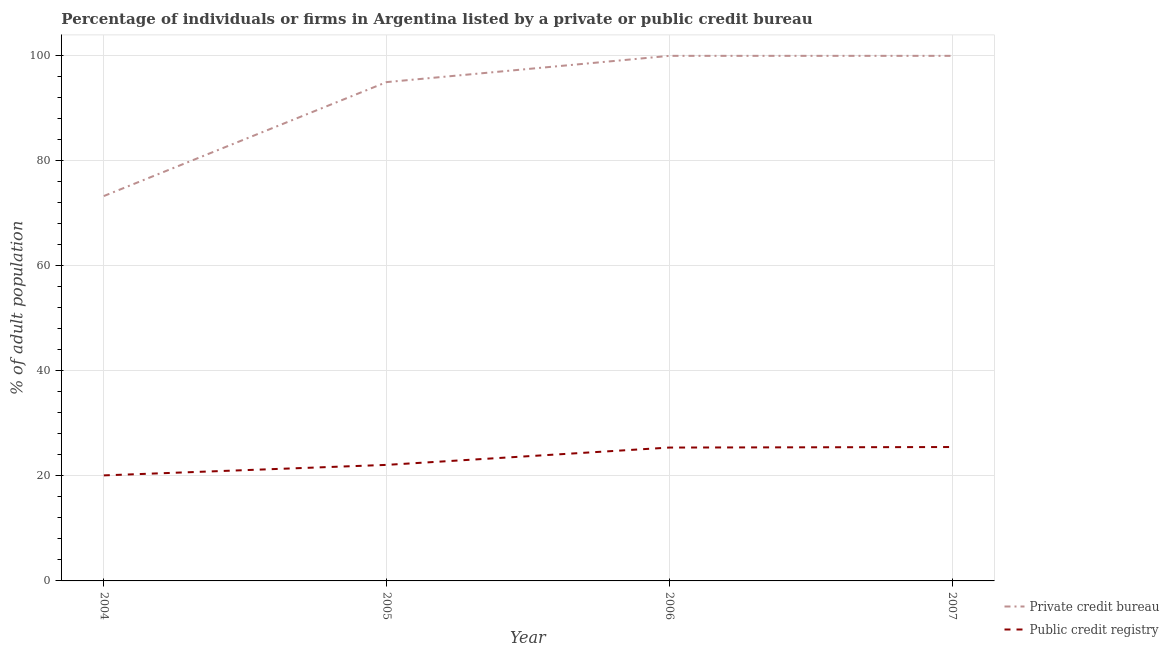How many different coloured lines are there?
Keep it short and to the point. 2. Does the line corresponding to percentage of firms listed by private credit bureau intersect with the line corresponding to percentage of firms listed by public credit bureau?
Your answer should be very brief. No. What is the percentage of firms listed by public credit bureau in 2004?
Give a very brief answer. 20.1. Across all years, what is the maximum percentage of firms listed by public credit bureau?
Give a very brief answer. 25.5. Across all years, what is the minimum percentage of firms listed by private credit bureau?
Provide a short and direct response. 73.3. In which year was the percentage of firms listed by public credit bureau maximum?
Give a very brief answer. 2007. In which year was the percentage of firms listed by private credit bureau minimum?
Give a very brief answer. 2004. What is the total percentage of firms listed by public credit bureau in the graph?
Keep it short and to the point. 93.1. What is the difference between the percentage of firms listed by public credit bureau in 2004 and that in 2007?
Give a very brief answer. -5.4. What is the difference between the percentage of firms listed by private credit bureau in 2004 and the percentage of firms listed by public credit bureau in 2007?
Offer a very short reply. 47.8. What is the average percentage of firms listed by public credit bureau per year?
Offer a terse response. 23.27. In the year 2005, what is the difference between the percentage of firms listed by private credit bureau and percentage of firms listed by public credit bureau?
Your answer should be very brief. 72.9. What is the ratio of the percentage of firms listed by public credit bureau in 2004 to that in 2007?
Give a very brief answer. 0.79. Is the percentage of firms listed by private credit bureau in 2004 less than that in 2007?
Provide a short and direct response. Yes. Is the difference between the percentage of firms listed by public credit bureau in 2005 and 2006 greater than the difference between the percentage of firms listed by private credit bureau in 2005 and 2006?
Ensure brevity in your answer.  Yes. What is the difference between the highest and the lowest percentage of firms listed by private credit bureau?
Provide a short and direct response. 26.7. In how many years, is the percentage of firms listed by public credit bureau greater than the average percentage of firms listed by public credit bureau taken over all years?
Provide a short and direct response. 2. Is the sum of the percentage of firms listed by public credit bureau in 2004 and 2007 greater than the maximum percentage of firms listed by private credit bureau across all years?
Offer a terse response. No. Is the percentage of firms listed by public credit bureau strictly greater than the percentage of firms listed by private credit bureau over the years?
Offer a terse response. No. How many lines are there?
Your response must be concise. 2. What is the difference between two consecutive major ticks on the Y-axis?
Keep it short and to the point. 20. Does the graph contain grids?
Your answer should be very brief. Yes. How many legend labels are there?
Ensure brevity in your answer.  2. What is the title of the graph?
Provide a succinct answer. Percentage of individuals or firms in Argentina listed by a private or public credit bureau. Does "Diarrhea" appear as one of the legend labels in the graph?
Make the answer very short. No. What is the label or title of the X-axis?
Your response must be concise. Year. What is the label or title of the Y-axis?
Ensure brevity in your answer.  % of adult population. What is the % of adult population in Private credit bureau in 2004?
Make the answer very short. 73.3. What is the % of adult population in Public credit registry in 2004?
Provide a short and direct response. 20.1. What is the % of adult population in Public credit registry in 2005?
Provide a short and direct response. 22.1. What is the % of adult population in Public credit registry in 2006?
Your response must be concise. 25.4. What is the % of adult population of Public credit registry in 2007?
Your response must be concise. 25.5. Across all years, what is the maximum % of adult population in Private credit bureau?
Provide a short and direct response. 100. Across all years, what is the maximum % of adult population in Public credit registry?
Offer a very short reply. 25.5. Across all years, what is the minimum % of adult population of Private credit bureau?
Make the answer very short. 73.3. Across all years, what is the minimum % of adult population in Public credit registry?
Offer a terse response. 20.1. What is the total % of adult population of Private credit bureau in the graph?
Keep it short and to the point. 368.3. What is the total % of adult population in Public credit registry in the graph?
Your answer should be very brief. 93.1. What is the difference between the % of adult population of Private credit bureau in 2004 and that in 2005?
Ensure brevity in your answer.  -21.7. What is the difference between the % of adult population of Private credit bureau in 2004 and that in 2006?
Offer a very short reply. -26.7. What is the difference between the % of adult population of Public credit registry in 2004 and that in 2006?
Provide a short and direct response. -5.3. What is the difference between the % of adult population in Private credit bureau in 2004 and that in 2007?
Offer a very short reply. -26.7. What is the difference between the % of adult population of Private credit bureau in 2005 and that in 2006?
Give a very brief answer. -5. What is the difference between the % of adult population in Public credit registry in 2005 and that in 2006?
Your answer should be compact. -3.3. What is the difference between the % of adult population of Private credit bureau in 2005 and that in 2007?
Give a very brief answer. -5. What is the difference between the % of adult population of Public credit registry in 2005 and that in 2007?
Make the answer very short. -3.4. What is the difference between the % of adult population of Public credit registry in 2006 and that in 2007?
Ensure brevity in your answer.  -0.1. What is the difference between the % of adult population in Private credit bureau in 2004 and the % of adult population in Public credit registry in 2005?
Provide a succinct answer. 51.2. What is the difference between the % of adult population in Private credit bureau in 2004 and the % of adult population in Public credit registry in 2006?
Keep it short and to the point. 47.9. What is the difference between the % of adult population in Private credit bureau in 2004 and the % of adult population in Public credit registry in 2007?
Your answer should be very brief. 47.8. What is the difference between the % of adult population in Private credit bureau in 2005 and the % of adult population in Public credit registry in 2006?
Your answer should be compact. 69.6. What is the difference between the % of adult population in Private credit bureau in 2005 and the % of adult population in Public credit registry in 2007?
Provide a short and direct response. 69.5. What is the difference between the % of adult population of Private credit bureau in 2006 and the % of adult population of Public credit registry in 2007?
Offer a very short reply. 74.5. What is the average % of adult population in Private credit bureau per year?
Offer a very short reply. 92.08. What is the average % of adult population in Public credit registry per year?
Ensure brevity in your answer.  23.27. In the year 2004, what is the difference between the % of adult population in Private credit bureau and % of adult population in Public credit registry?
Make the answer very short. 53.2. In the year 2005, what is the difference between the % of adult population in Private credit bureau and % of adult population in Public credit registry?
Offer a terse response. 72.9. In the year 2006, what is the difference between the % of adult population of Private credit bureau and % of adult population of Public credit registry?
Your answer should be very brief. 74.6. In the year 2007, what is the difference between the % of adult population of Private credit bureau and % of adult population of Public credit registry?
Give a very brief answer. 74.5. What is the ratio of the % of adult population in Private credit bureau in 2004 to that in 2005?
Offer a terse response. 0.77. What is the ratio of the % of adult population of Public credit registry in 2004 to that in 2005?
Ensure brevity in your answer.  0.91. What is the ratio of the % of adult population of Private credit bureau in 2004 to that in 2006?
Provide a succinct answer. 0.73. What is the ratio of the % of adult population in Public credit registry in 2004 to that in 2006?
Provide a succinct answer. 0.79. What is the ratio of the % of adult population of Private credit bureau in 2004 to that in 2007?
Offer a terse response. 0.73. What is the ratio of the % of adult population in Public credit registry in 2004 to that in 2007?
Give a very brief answer. 0.79. What is the ratio of the % of adult population of Public credit registry in 2005 to that in 2006?
Provide a short and direct response. 0.87. What is the ratio of the % of adult population in Private credit bureau in 2005 to that in 2007?
Your answer should be very brief. 0.95. What is the ratio of the % of adult population of Public credit registry in 2005 to that in 2007?
Your answer should be very brief. 0.87. What is the ratio of the % of adult population in Public credit registry in 2006 to that in 2007?
Offer a very short reply. 1. What is the difference between the highest and the second highest % of adult population of Private credit bureau?
Offer a very short reply. 0. What is the difference between the highest and the second highest % of adult population of Public credit registry?
Offer a very short reply. 0.1. What is the difference between the highest and the lowest % of adult population in Private credit bureau?
Your answer should be compact. 26.7. 